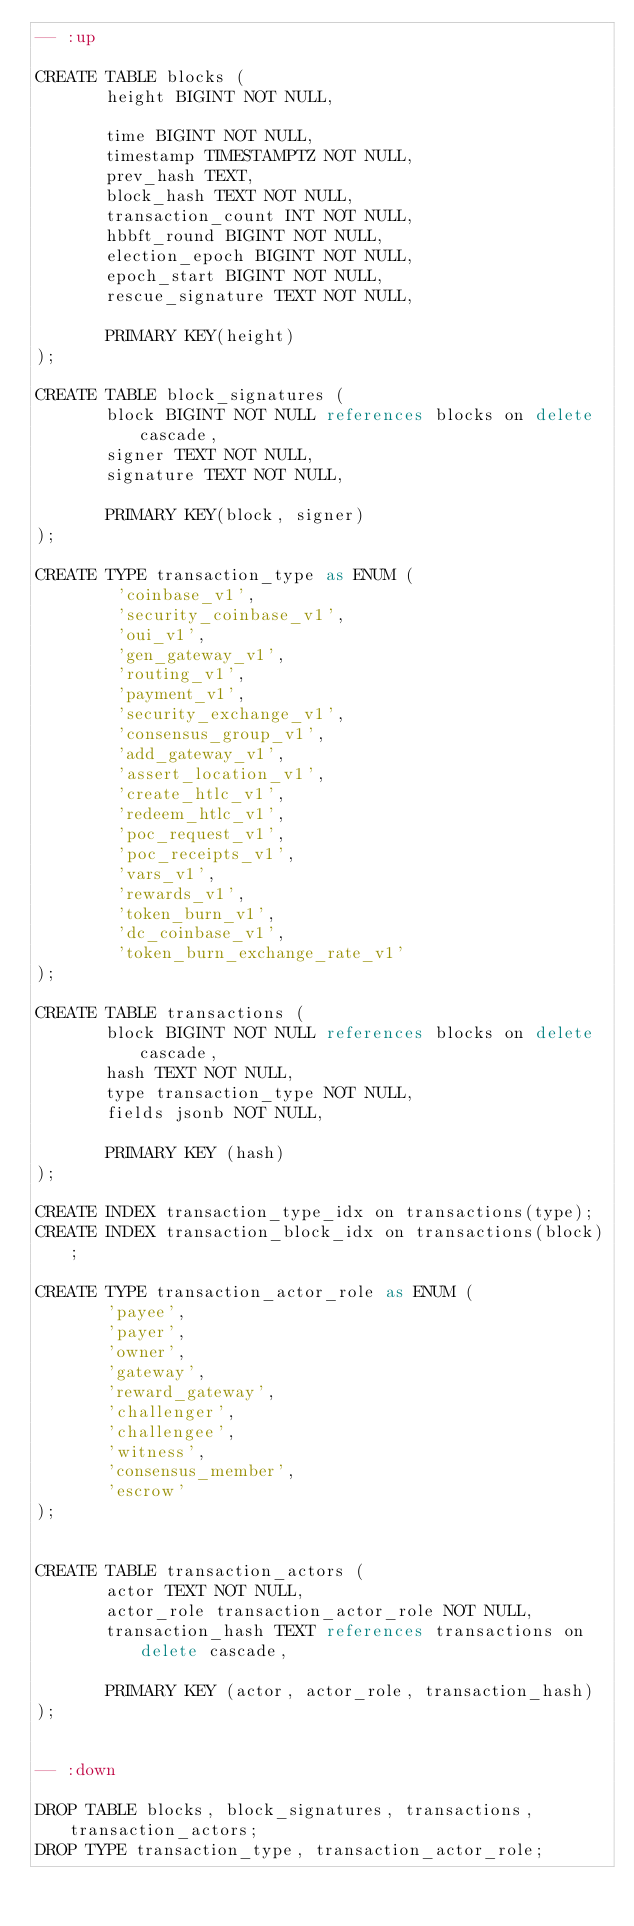<code> <loc_0><loc_0><loc_500><loc_500><_SQL_>-- :up

CREATE TABLE blocks (
       height BIGINT NOT NULL,

       time BIGINT NOT NULL,
       timestamp TIMESTAMPTZ NOT NULL,
       prev_hash TEXT,
       block_hash TEXT NOT NULL,
       transaction_count INT NOT NULL,
       hbbft_round BIGINT NOT NULL,
       election_epoch BIGINT NOT NULL,
       epoch_start BIGINT NOT NULL,
       rescue_signature TEXT NOT NULL,

       PRIMARY KEY(height)
);

CREATE TABLE block_signatures (
       block BIGINT NOT NULL references blocks on delete cascade,
       signer TEXT NOT NULL,
       signature TEXT NOT NULL,

       PRIMARY KEY(block, signer)
);

CREATE TYPE transaction_type as ENUM (
        'coinbase_v1',
        'security_coinbase_v1',
        'oui_v1',
        'gen_gateway_v1',
        'routing_v1',
        'payment_v1',
        'security_exchange_v1',
        'consensus_group_v1',
        'add_gateway_v1',
        'assert_location_v1',
        'create_htlc_v1',
        'redeem_htlc_v1',
        'poc_request_v1',
        'poc_receipts_v1',
        'vars_v1',
        'rewards_v1',
        'token_burn_v1',
        'dc_coinbase_v1',
        'token_burn_exchange_rate_v1'
);

CREATE TABLE transactions (
       block BIGINT NOT NULL references blocks on delete cascade,
       hash TEXT NOT NULL,
       type transaction_type NOT NULL,
       fields jsonb NOT NULL,

       PRIMARY KEY (hash)
);

CREATE INDEX transaction_type_idx on transactions(type);
CREATE INDEX transaction_block_idx on transactions(block);

CREATE TYPE transaction_actor_role as ENUM (
       'payee',
       'payer',
       'owner',
       'gateway',
       'reward_gateway',
       'challenger',
       'challengee',
       'witness',
       'consensus_member',
       'escrow'
);


CREATE TABLE transaction_actors (
       actor TEXT NOT NULL,
       actor_role transaction_actor_role NOT NULL,
       transaction_hash TEXT references transactions on delete cascade,

       PRIMARY KEY (actor, actor_role, transaction_hash)
);


-- :down

DROP TABLE blocks, block_signatures, transactions, transaction_actors;
DROP TYPE transaction_type, transaction_actor_role;
</code> 